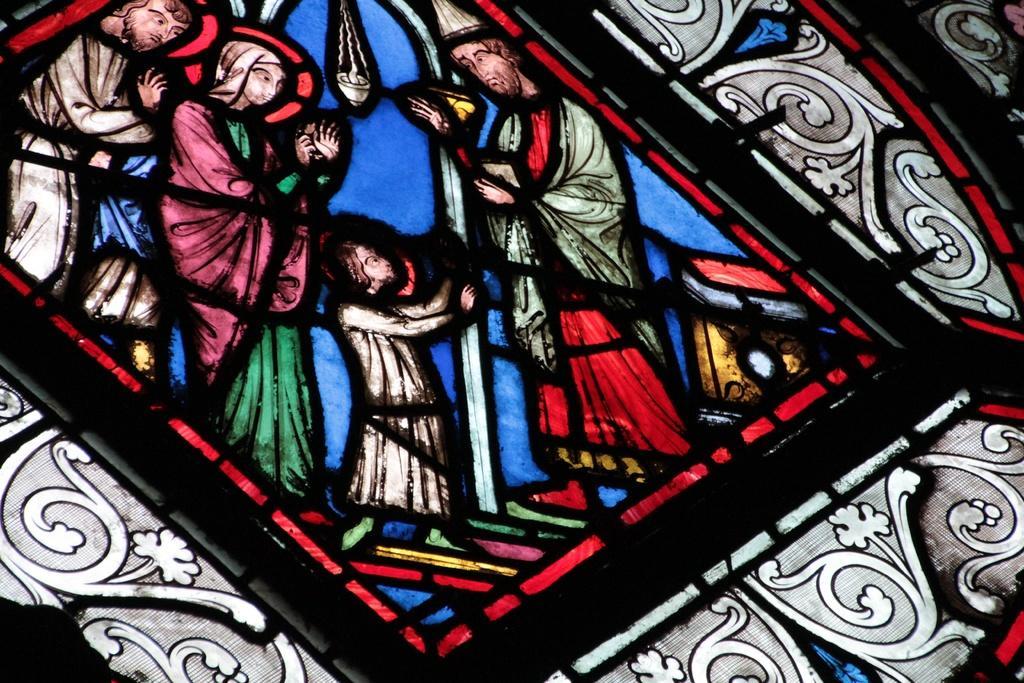Could you give a brief overview of what you see in this image? In this picture there is an object which seems to be the stained glass with the depictions. In the center we can see the group of people standing and there is an object which seems to be hanging and we can see the depictions of flowers and the depictions of some other objects. 